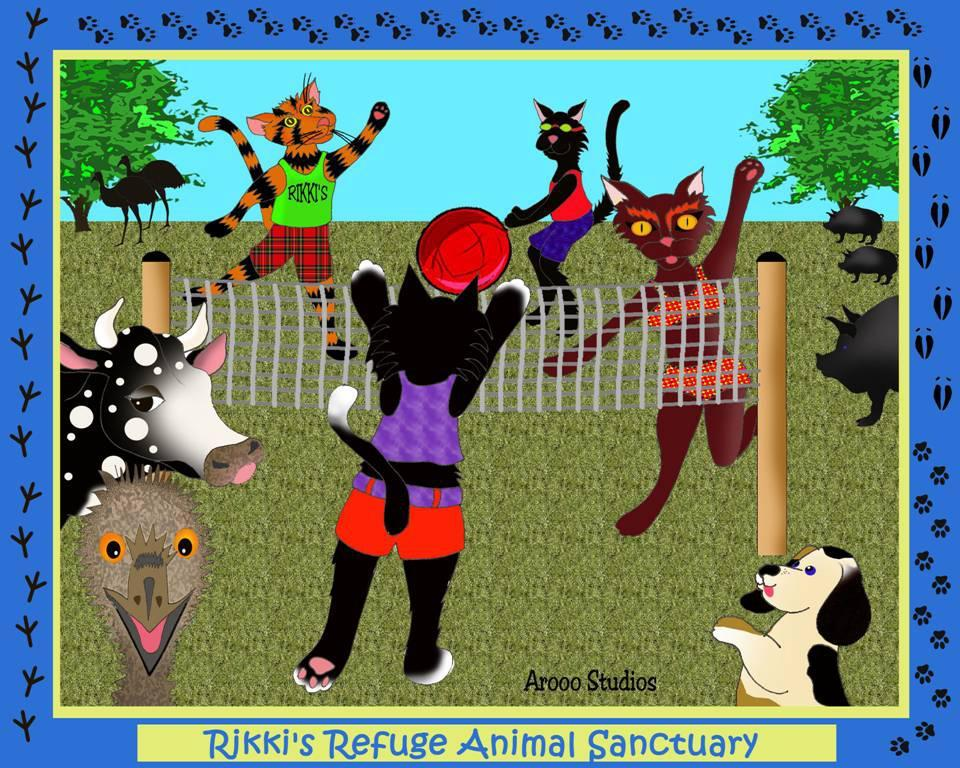What is featured on the poster in the image? The poster contains images of animals. What else can be seen on the poster besides the animal images? There is text on the poster. What object is present in the image that could be used for catching or holding? There is a net in the image. What type of natural environment is visible in the image? Trees are present in the image, suggesting a natural setting. What living creatures can be seen in the image besides the animals on the poster? Birds are visible in the image. What type of nail can be seen holding the poster in the image? There is no nail visible in the image; the poster is not attached to anything in the image. What type of grain is visible in the image? There is no grain present in the image. 